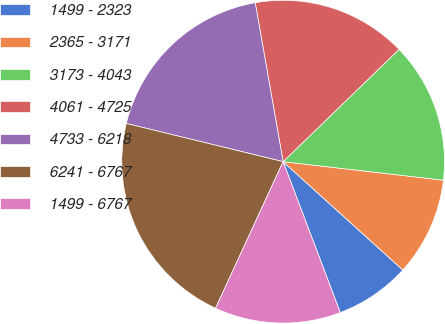Convert chart to OTSL. <chart><loc_0><loc_0><loc_500><loc_500><pie_chart><fcel>1499 - 2323<fcel>2365 - 3171<fcel>3173 - 4043<fcel>4061 - 4725<fcel>4733 - 6218<fcel>6241 - 6767<fcel>1499 - 6767<nl><fcel>7.53%<fcel>9.88%<fcel>14.08%<fcel>15.52%<fcel>18.43%<fcel>21.93%<fcel>12.64%<nl></chart> 